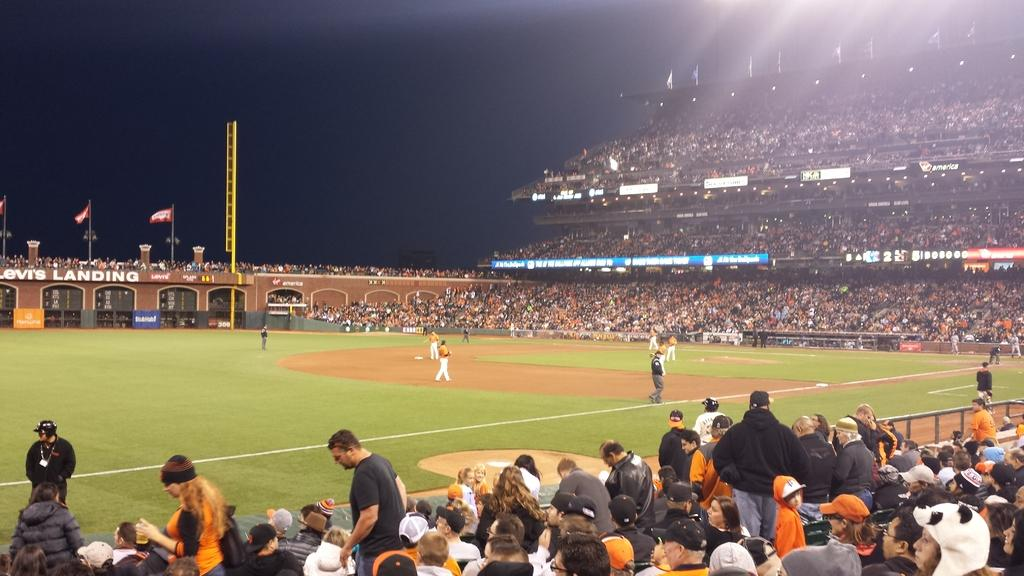What type of structure is shown in the picture? There is a stadium in the picture. What can be seen on the ground inside the stadium? There are people standing on the ground in the stadium. Who is present in the stadium besides the people on the ground? There is an audience in the picture. What decorative elements can be seen in the picture? There are flags visible in the picture. What is visible in the background of the picture? The sky is visible in the picture. What type of dock can be seen near the stadium in the image? There is no dock present in the image; it features a stadium with people, an audience, flags, and a visible sky. What type of eggnog is being served to the audience in the image? There is no mention of eggnog or any food or drink in the image; it only shows a stadium with people, an audience, flags, and a visible sky. 